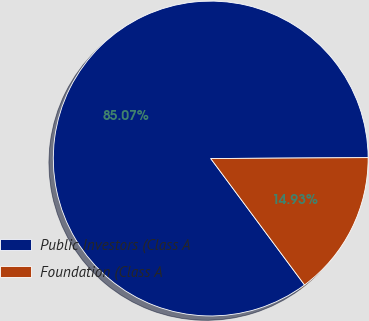<chart> <loc_0><loc_0><loc_500><loc_500><pie_chart><fcel>Public Investors (Class A<fcel>Foundation (Class A<nl><fcel>85.07%<fcel>14.93%<nl></chart> 